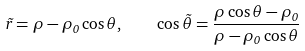Convert formula to latex. <formula><loc_0><loc_0><loc_500><loc_500>\tilde { r } = \rho - \rho _ { 0 } \cos \theta , \quad \cos \tilde { \theta } = \frac { \rho \cos \theta - \rho _ { 0 } } { \rho - \rho _ { 0 } \cos \theta }</formula> 